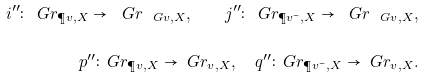Convert formula to latex. <formula><loc_0><loc_0><loc_500><loc_500>i ^ { \prime \prime } \colon \ G r _ { \P v , X } \to \ G r _ { \ G v , X } , \quad j ^ { \prime \prime } \colon \ G r _ { \P v ^ { - } , X } \to \ G r _ { \ G v , X } , \\ p ^ { \prime \prime } \colon \ G r _ { \P v , X } \to \ G r _ { \L v , X } , \quad q ^ { \prime \prime } \colon \ G r _ { \P v ^ { - } , X } \to \ G r _ { \L v , X } .</formula> 